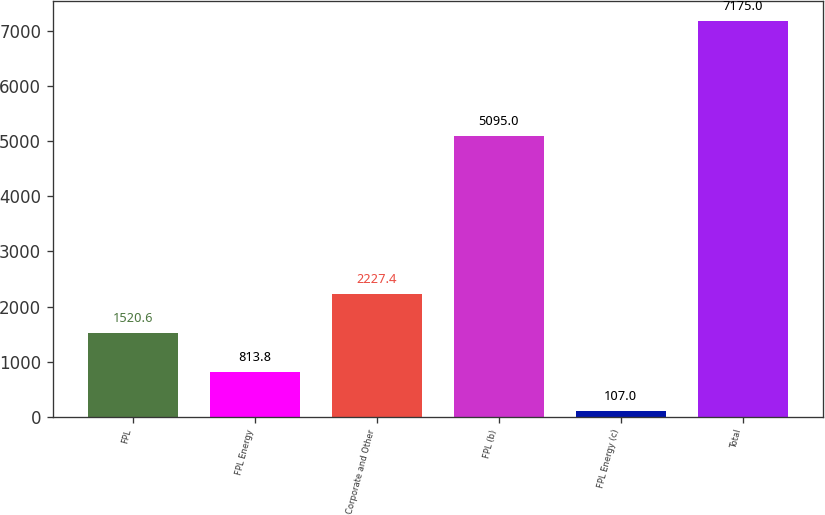Convert chart. <chart><loc_0><loc_0><loc_500><loc_500><bar_chart><fcel>FPL<fcel>FPL Energy<fcel>Corporate and Other<fcel>FPL (b)<fcel>FPL Energy (c)<fcel>Total<nl><fcel>1520.6<fcel>813.8<fcel>2227.4<fcel>5095<fcel>107<fcel>7175<nl></chart> 